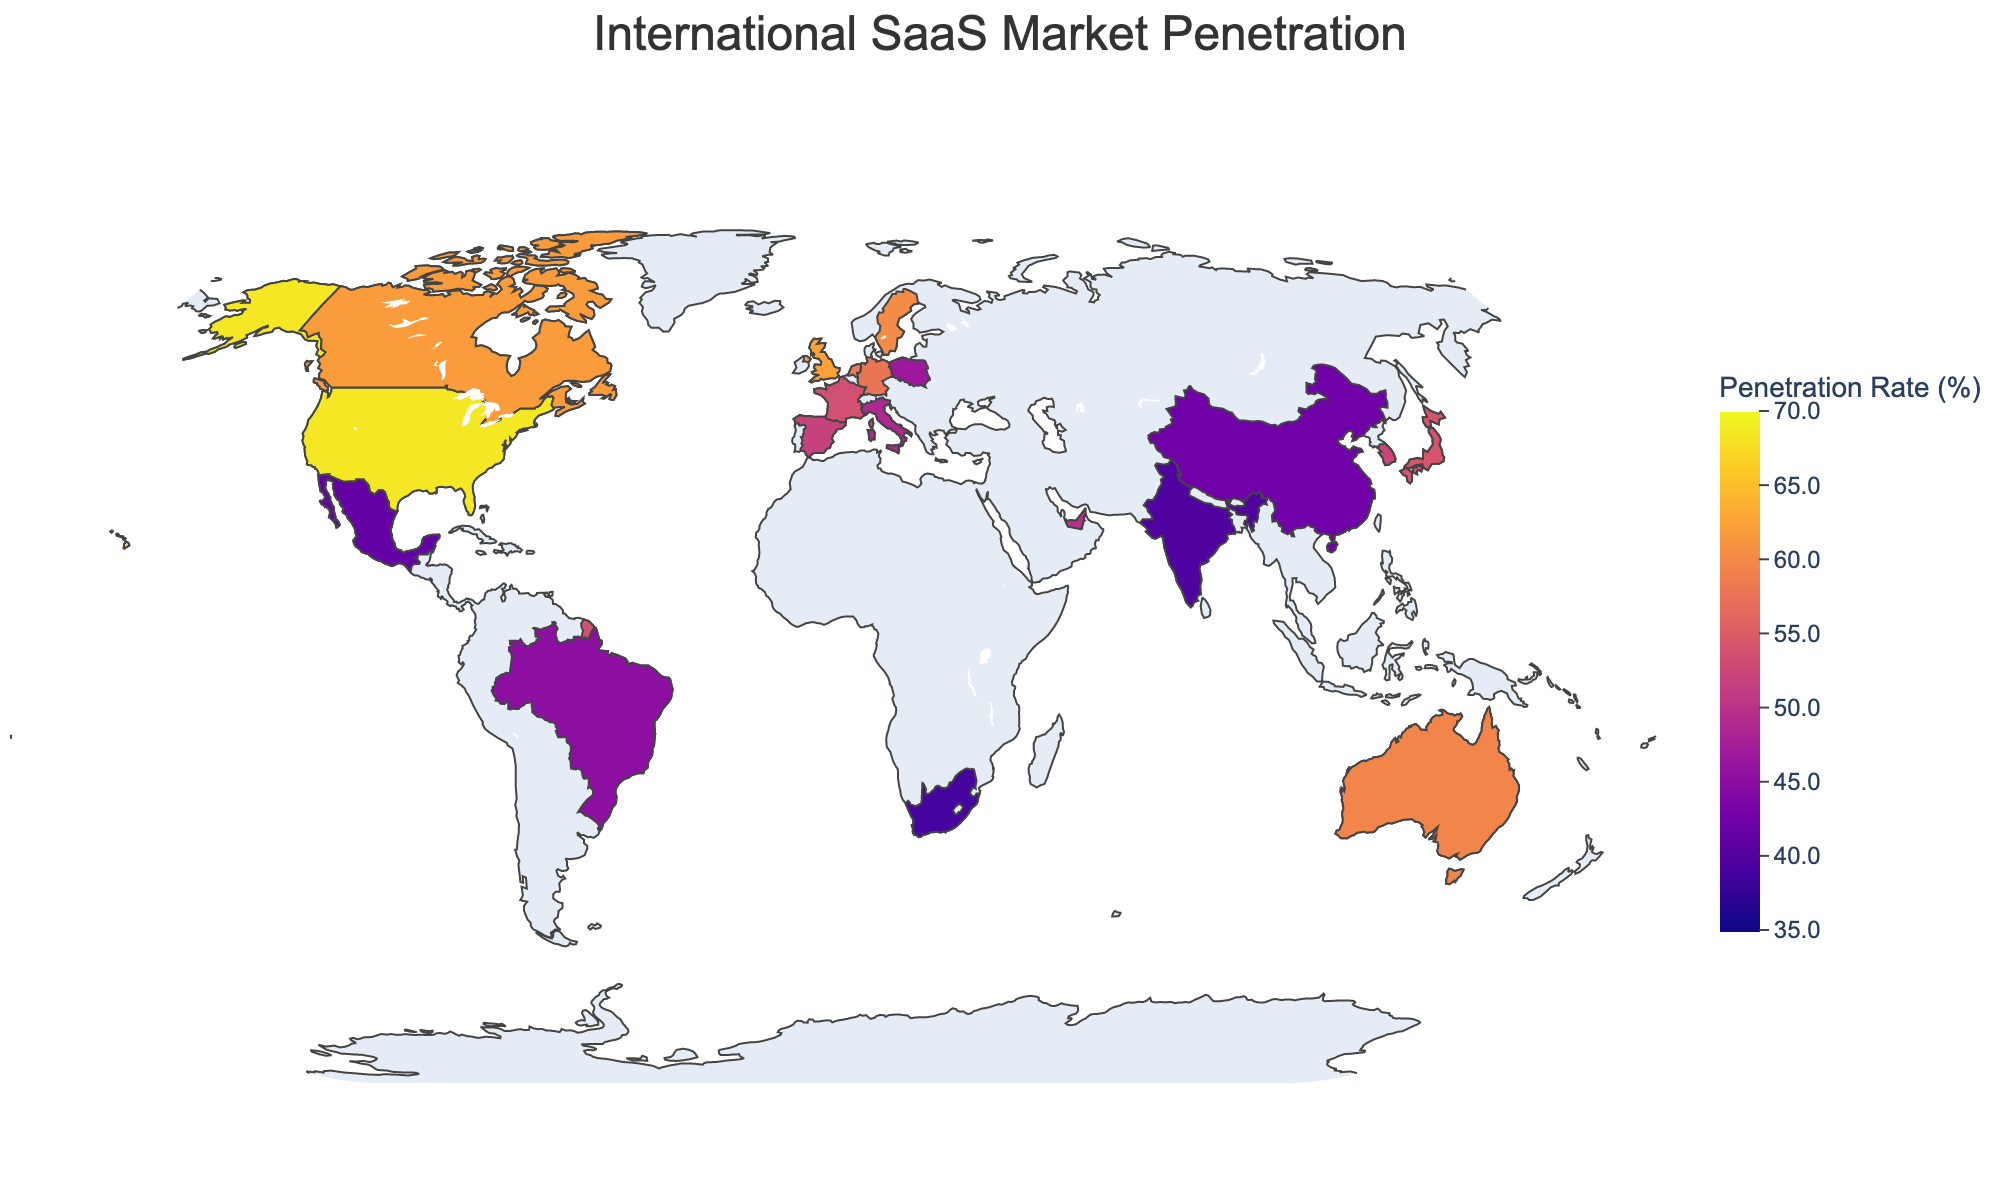What's the title of the figure? The title of the figure is usually displayed prominently at the top of the graphic. In this case, it is indicated in the code.
Answer: International SaaS Market Penetration Which country has the highest SaaS penetration rate? By looking at the color intensity on the map and the corresponding values, we can identify that the United States has the deepest color, indicating the highest penetration rate.
Answer: United States What's the penetration rate of SaaS products in France? To find this, look at the map and hover over France to see the SaaS penetration rate displayed.
Answer: 53.6% Which region (North America, Europe, Asia) has more countries with higher SaaS penetration rates? Compare the map colors and numbers for countries in North America (United States, Canada), Europe (United Kingdom, Germany, France, Netherlands, Sweden, Spain, Italy, Poland), and Asia (Japan, Singapore, South Korea, China, India) to see which region predominantly displays higher values.
Answer: Europe What is the approximate average SaaS penetration rate for the listed countries? To find the average, sum up all the SaaS penetration rates and then divide by the number of countries. Sum = 68.5 + 62.3 + 57.8 + 54.2 + 61.9 + 59.7 + 53.6 + 58.4 + 56.1 + 60.2 + 45.3 + 39.8 + 42.6 + 51.9 + 48.7 + 52.3 + 41.5 + 38.9 + 49.6 + 46.8. Total = 971.3. There are 20 countries, so 971.3 / 20 = 48.565.
Answer: 48.6% Which country in Asia has the lowest SaaS penetration rate? To find this, look at the map and hover over the countries in Asia (Japan, Singapore, South Korea, China, India) and compare their penetration rates.
Answer: India Is the SaaS penetration rate higher in Brazil or Mexico? Hover over Brazil and Mexico on the map, compare their displayed penetration rates to identify which one is higher.
Answer: Brazil How many countries have a SaaS penetration rate above 50%? Count the number of countries displayed on the map with SaaS penetration rates greater than 50%.
Answer: 12 What is the range of SaaS penetration rates shown on the map? The range can be found by identifying the minimum and maximum penetration rates in the data. The lowest is South Africa at 38.9% and the highest is the United States at 68.5%. Range = 68.5 - 38.9.
Answer: 29.6 Which European country has a SaaS penetration rate closest to 60%? Look at the European countries (United Kingdom, Germany, France, Netherlands, Sweden, Spain, Italy, Poland) and see which one has a rate closest to 60% by checking the values.
Answer: Sweden 